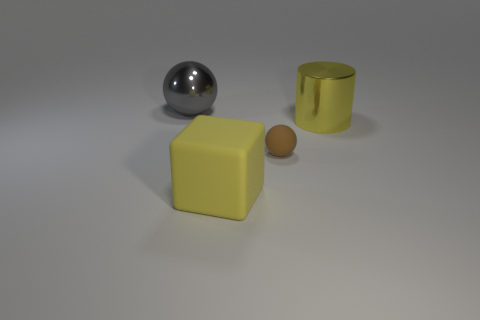There is a metal object that is on the right side of the yellow object left of the large yellow object behind the rubber cube; what shape is it?
Keep it short and to the point. Cylinder. Are the large yellow object that is on the right side of the yellow matte cube and the sphere on the right side of the large yellow rubber object made of the same material?
Provide a short and direct response. No. What is the material of the small sphere?
Keep it short and to the point. Rubber. How many large gray objects are the same shape as the brown rubber object?
Keep it short and to the point. 1. There is a big block that is the same color as the cylinder; what is it made of?
Keep it short and to the point. Rubber. Is there anything else that has the same shape as the big yellow matte thing?
Make the answer very short. No. There is a large metallic object that is left of the yellow cylinder that is behind the big thing that is in front of the yellow shiny object; what is its color?
Your response must be concise. Gray. What number of small things are either metal balls or metal objects?
Provide a succinct answer. 0. Is the number of yellow rubber cubes behind the gray thing the same as the number of tiny brown things?
Ensure brevity in your answer.  No. There is a gray shiny ball; are there any metal things behind it?
Provide a short and direct response. No. 